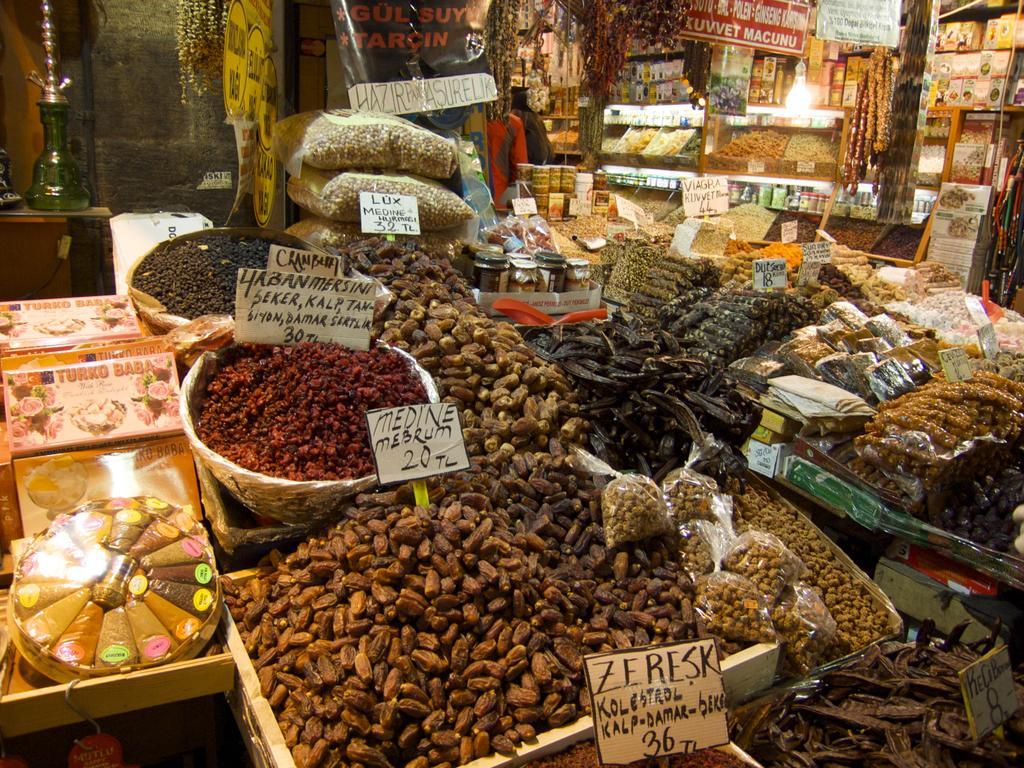In one or two sentences, can you explain what this image depicts? In this image I can see there is a grocery shop. And there are some dry fruits and eatable items in it. And there are boards with text. And there is a table. On the table there is a hookah and there is a wall. And there is a person standing. 